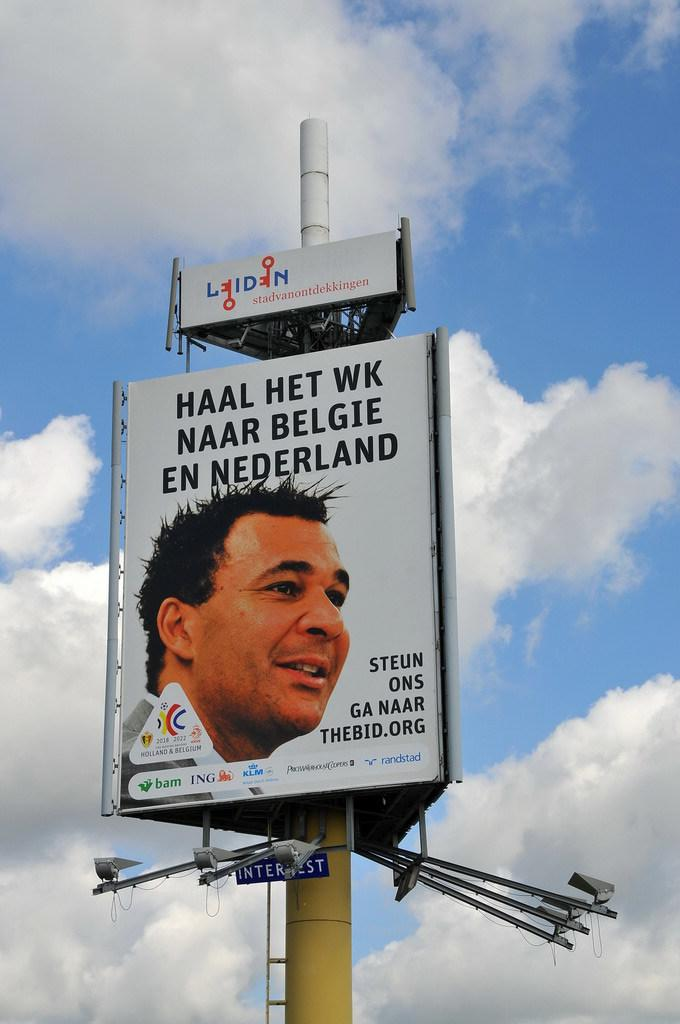Provide a one-sentence caption for the provided image. A billboard in a foreign language of a man with dark hair. 